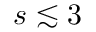<formula> <loc_0><loc_0><loc_500><loc_500>s \lesssim 3</formula> 